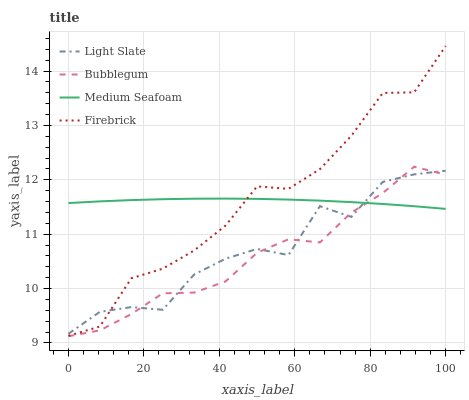Does Bubblegum have the minimum area under the curve?
Answer yes or no. Yes. Does Firebrick have the maximum area under the curve?
Answer yes or no. Yes. Does Medium Seafoam have the minimum area under the curve?
Answer yes or no. No. Does Medium Seafoam have the maximum area under the curve?
Answer yes or no. No. Is Medium Seafoam the smoothest?
Answer yes or no. Yes. Is Light Slate the roughest?
Answer yes or no. Yes. Is Firebrick the smoothest?
Answer yes or no. No. Is Firebrick the roughest?
Answer yes or no. No. Does Bubblegum have the lowest value?
Answer yes or no. Yes. Does Firebrick have the lowest value?
Answer yes or no. No. Does Firebrick have the highest value?
Answer yes or no. Yes. Does Medium Seafoam have the highest value?
Answer yes or no. No. Is Bubblegum less than Firebrick?
Answer yes or no. Yes. Is Firebrick greater than Bubblegum?
Answer yes or no. Yes. Does Firebrick intersect Medium Seafoam?
Answer yes or no. Yes. Is Firebrick less than Medium Seafoam?
Answer yes or no. No. Is Firebrick greater than Medium Seafoam?
Answer yes or no. No. Does Bubblegum intersect Firebrick?
Answer yes or no. No. 